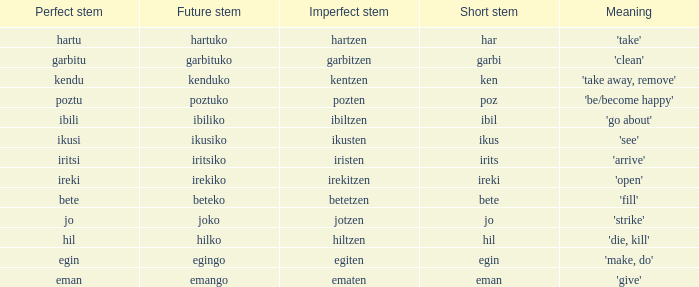Identify the flawless stem for "jo". 1.0. 